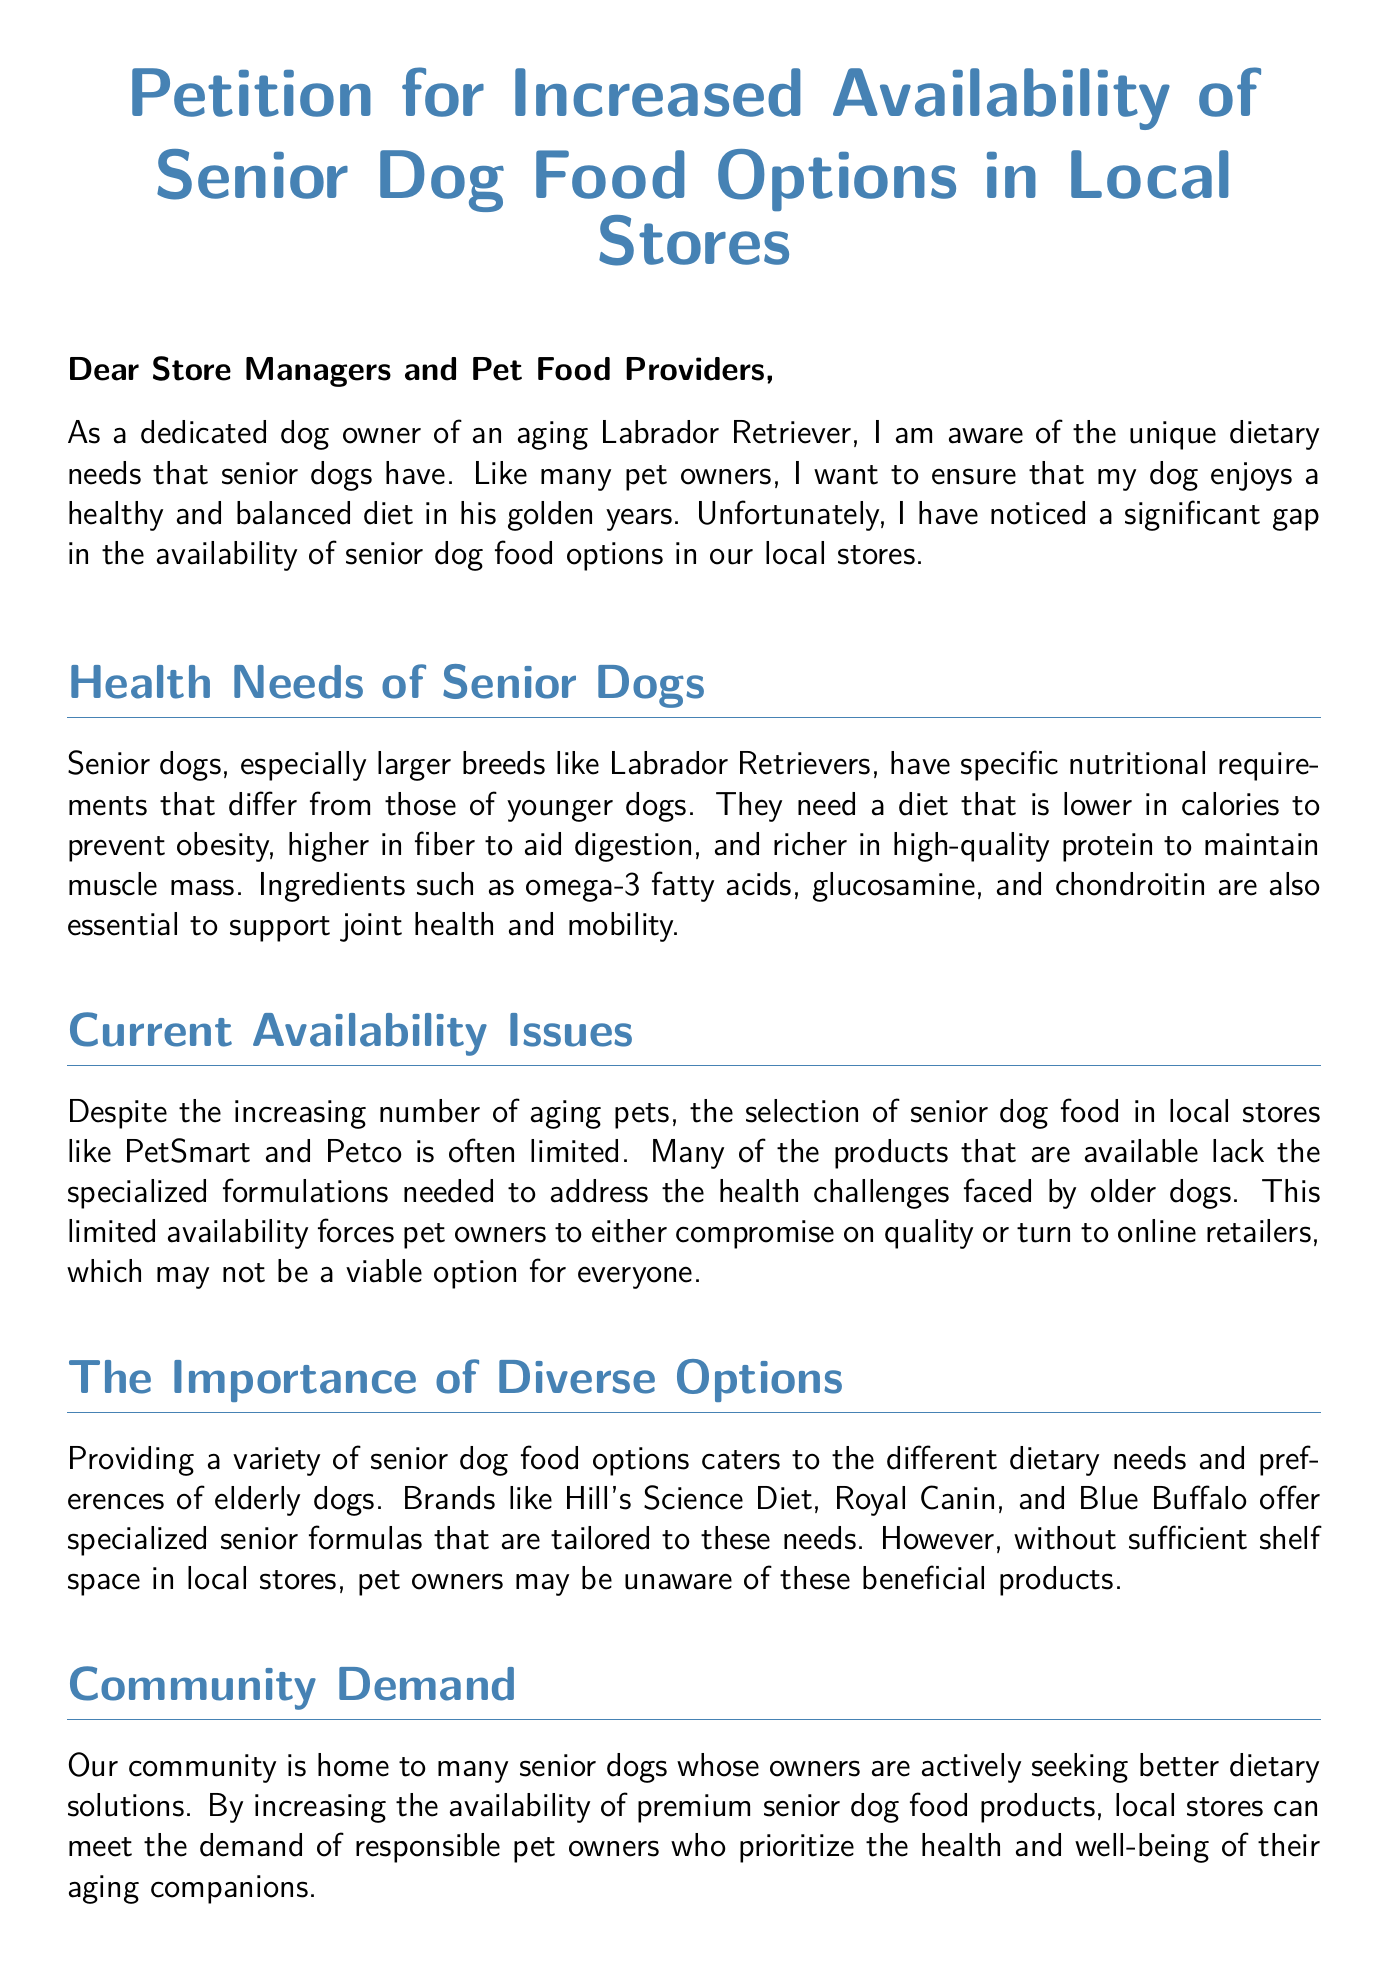What is the main request of the petition? The petition requests an increase in the availability of senior dog food options in local stores.
Answer: Increased availability of senior dog food options Who is the target audience of the petition? The target audience is store managers and pet food providers.
Answer: Store managers and pet food providers What specific health ingredients are mentioned for senior dogs? Omega-3 fatty acids, glucosamine, and chondroitin are mentioned as essential for joint health and mobility.
Answer: Omega-3 fatty acids, glucosamine, and chondroitin Which breeds are specifically noted as having unique dietary needs? Larger breeds like Labrador Retrievers are specifically noted.
Answer: Labrador Retrievers What is mentioned as a common problem with current senior dog food availability? The current problem is that the selection of senior dog food is often limited.
Answer: Limited selection of senior dog food Name one brand mentioned that offers specialized senior dog food formulations. Hill's Science Diet is mentioned as a brand that offers specialized products.
Answer: Hill's Science Diet What does the petition suggest will benefit the community? The petition suggests that expanding senior dog food options will improve the health and happiness of senior dogs.
Answer: Improve health and happiness of senior dogs How do pet owners currently feel about the available options? Pet owners feel they have to compromise on quality or use online retailers.
Answer: Compromise on quality or use online retailers What is the goal of the petition according to the closing statements? The goal is to improve the quality of life for aging pets.
Answer: Improve quality of life for aging pets 